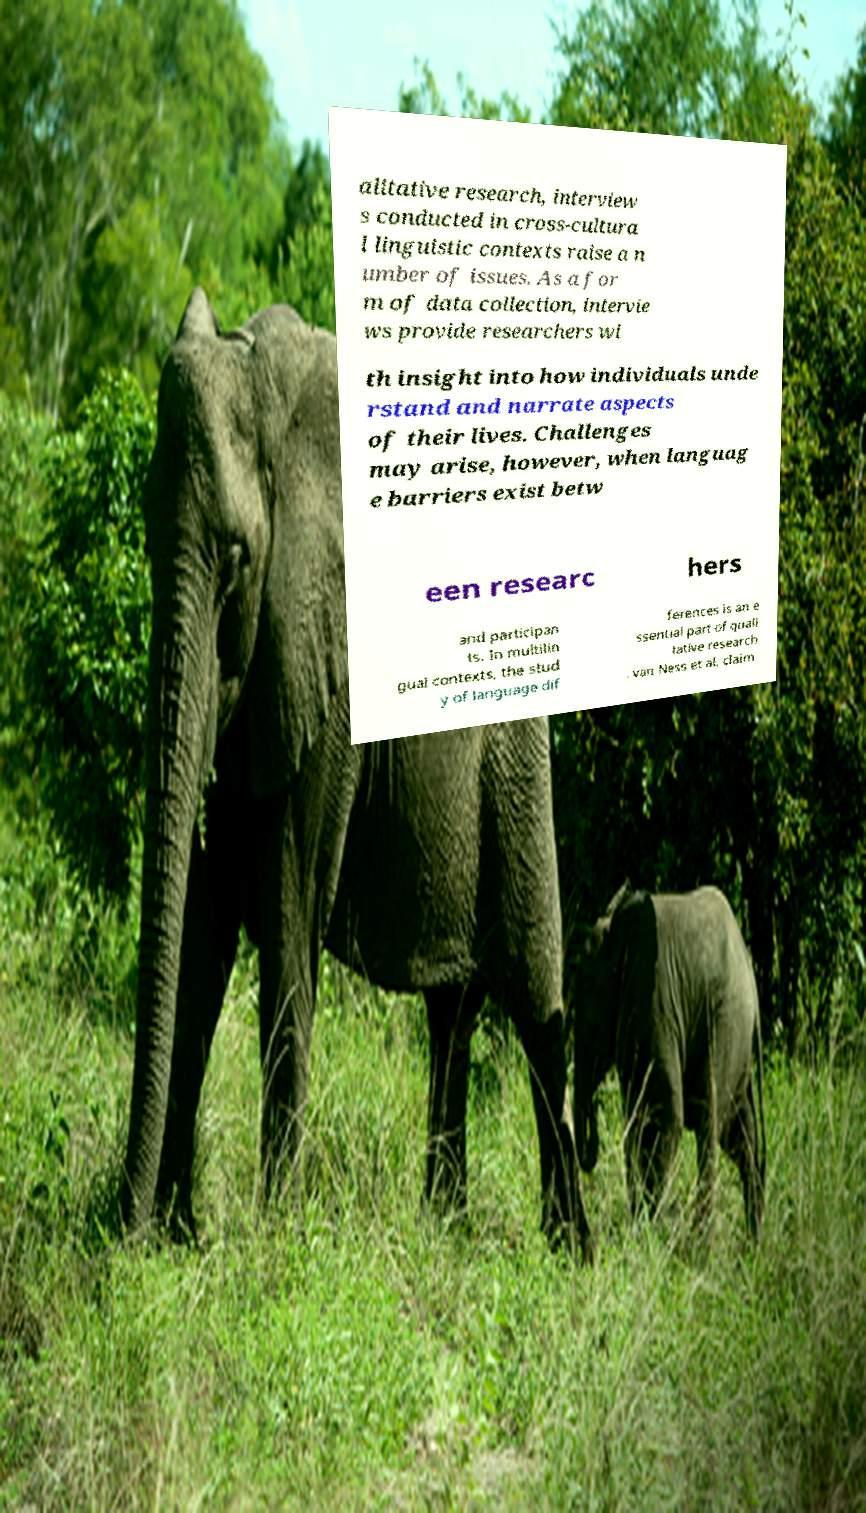What messages or text are displayed in this image? I need them in a readable, typed format. alitative research, interview s conducted in cross-cultura l linguistic contexts raise a n umber of issues. As a for m of data collection, intervie ws provide researchers wi th insight into how individuals unde rstand and narrate aspects of their lives. Challenges may arise, however, when languag e barriers exist betw een researc hers and participan ts. In multilin gual contexts, the stud y of language dif ferences is an e ssential part of quali tative research . van Ness et al. claim 